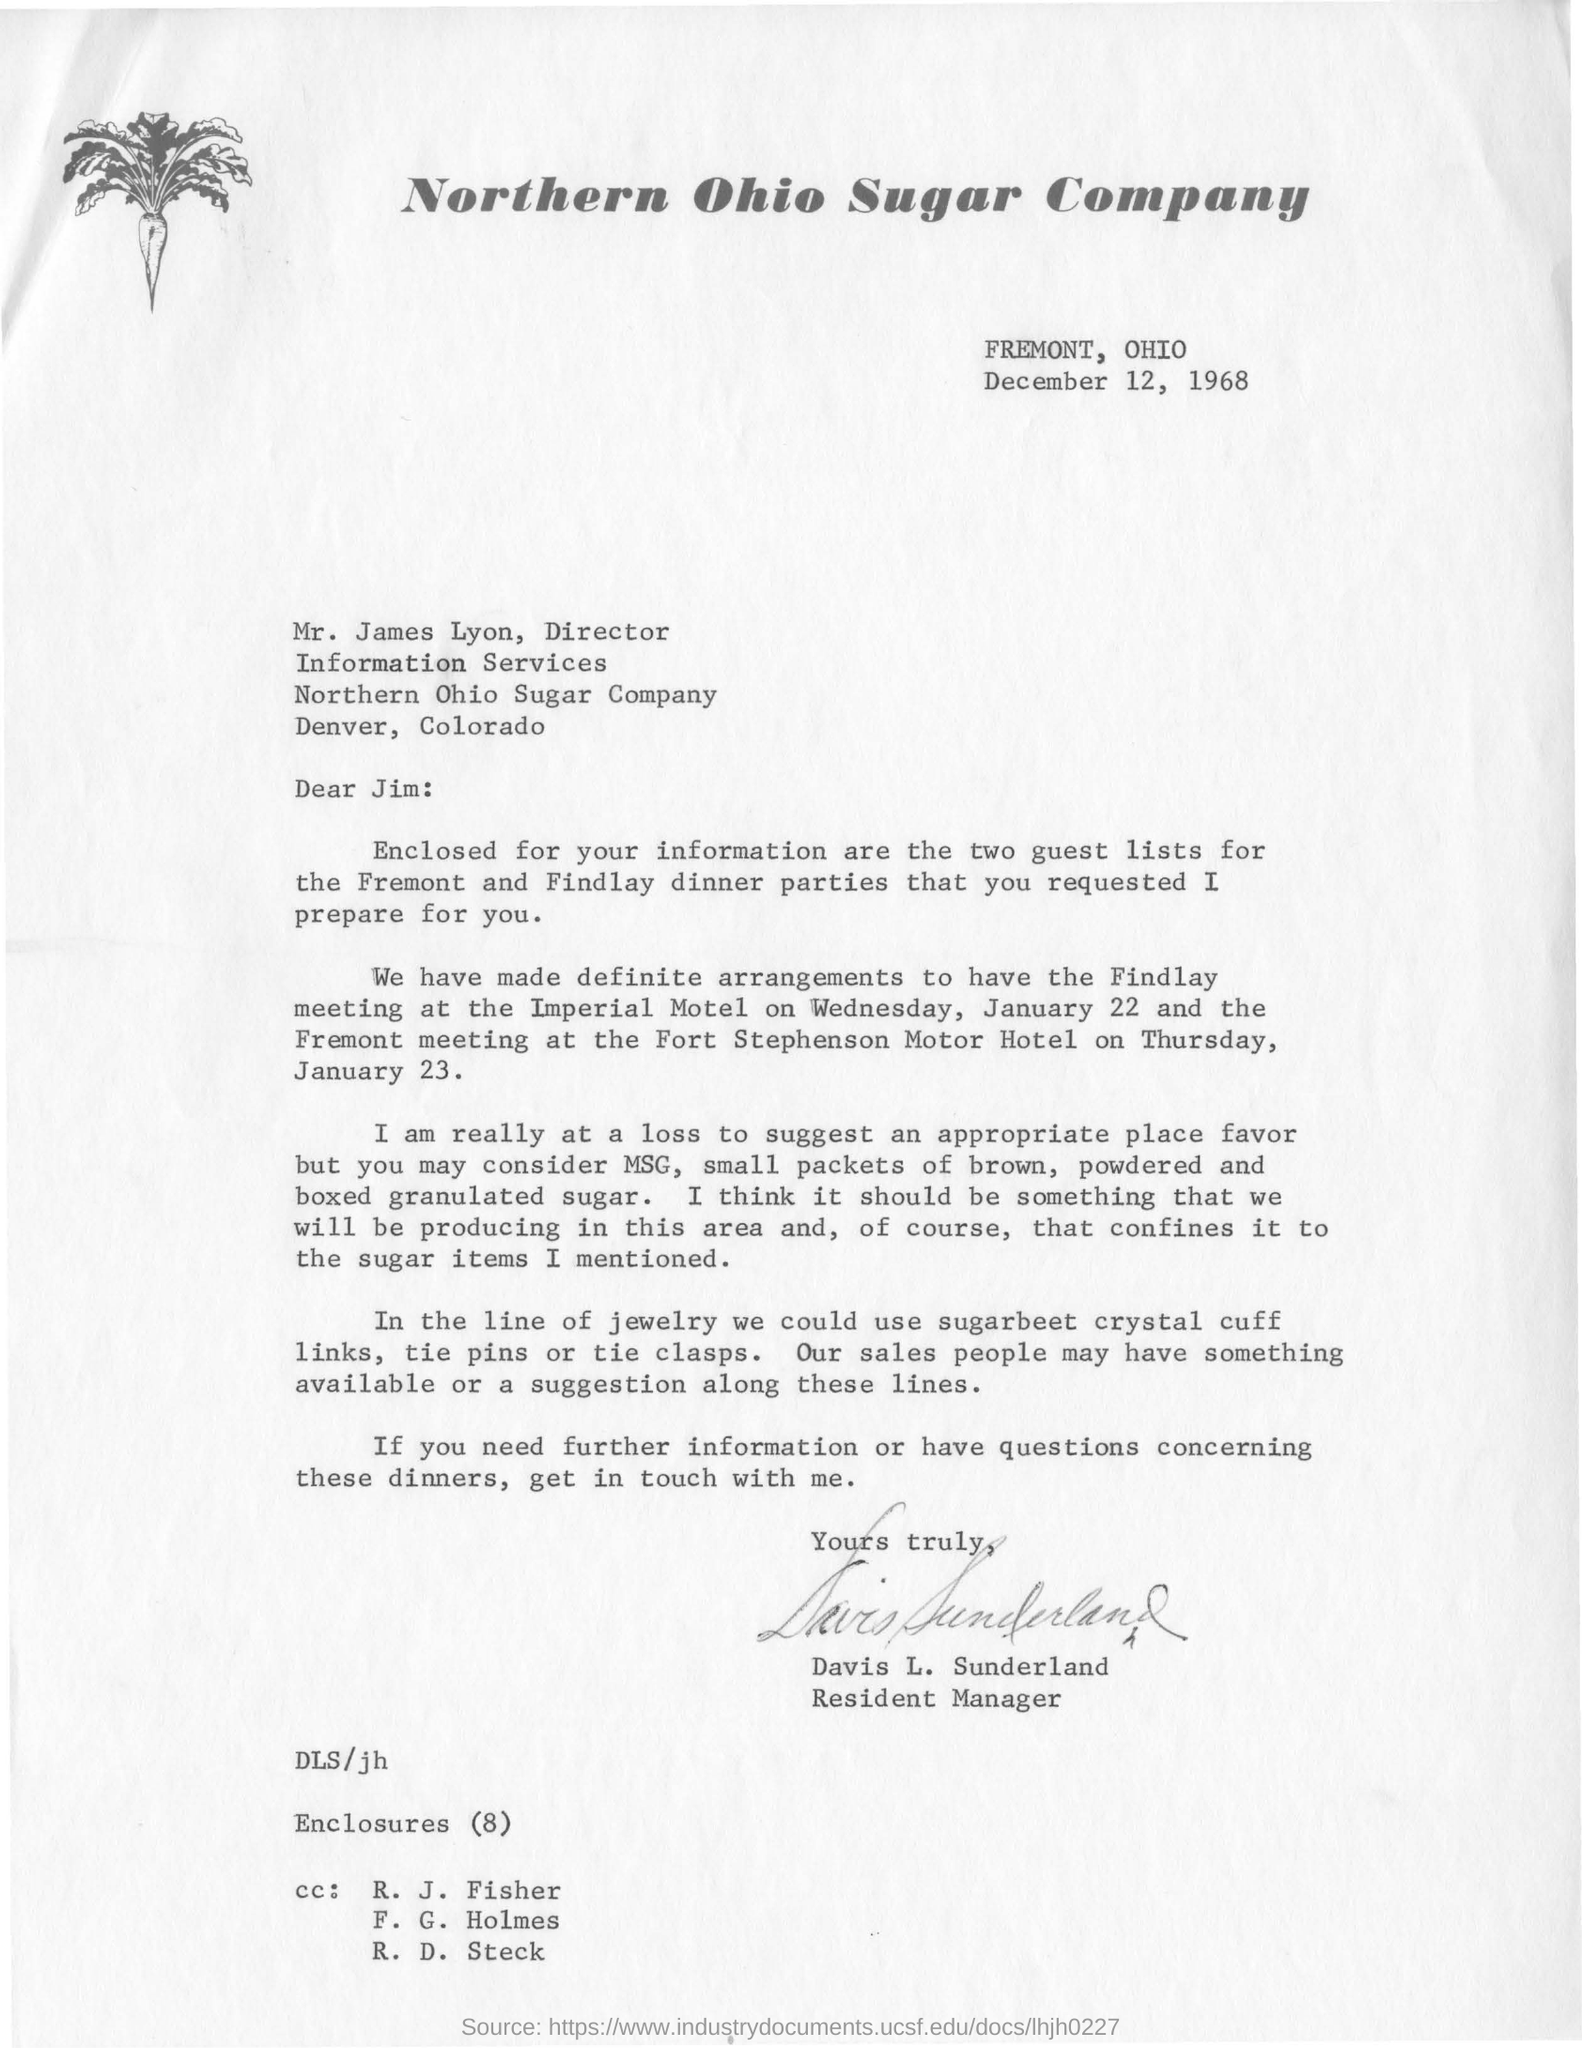Specify some key components in this picture. The date mentioned above is December 12, 1968. The Northern Ohio Sugar Company is the name of the company. The letterhead mentions the Northern Ohio Sugar Company. 